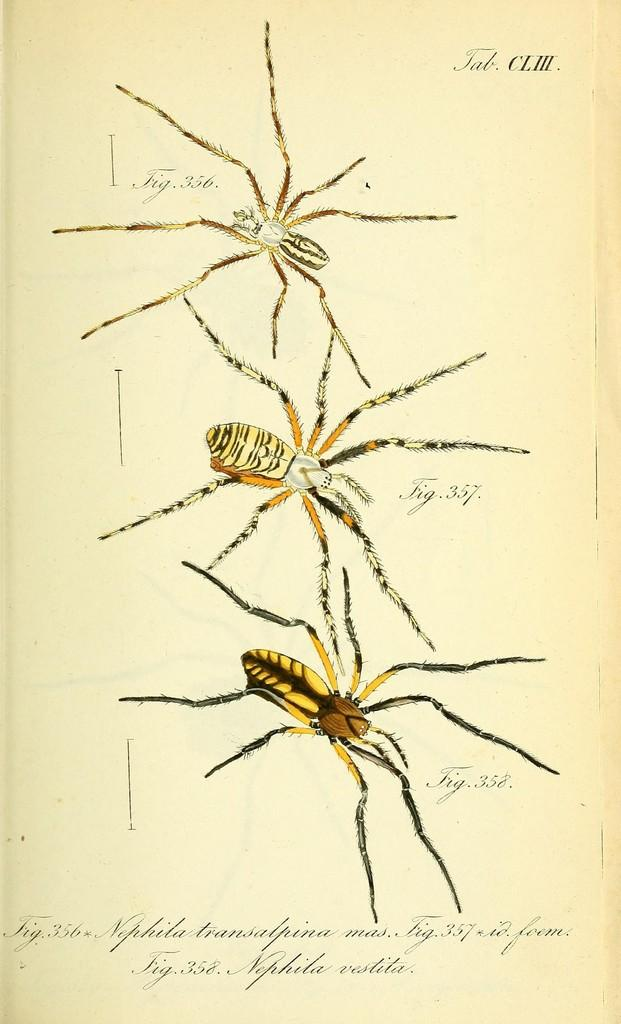How many insects are present on the page? There are three insects on the page. What else can be found on the page besides the insects? There is text on the page. Where is the girl standing with the hen in the image? There is no girl or hen present in the image; it only features three insects and text on the page. 